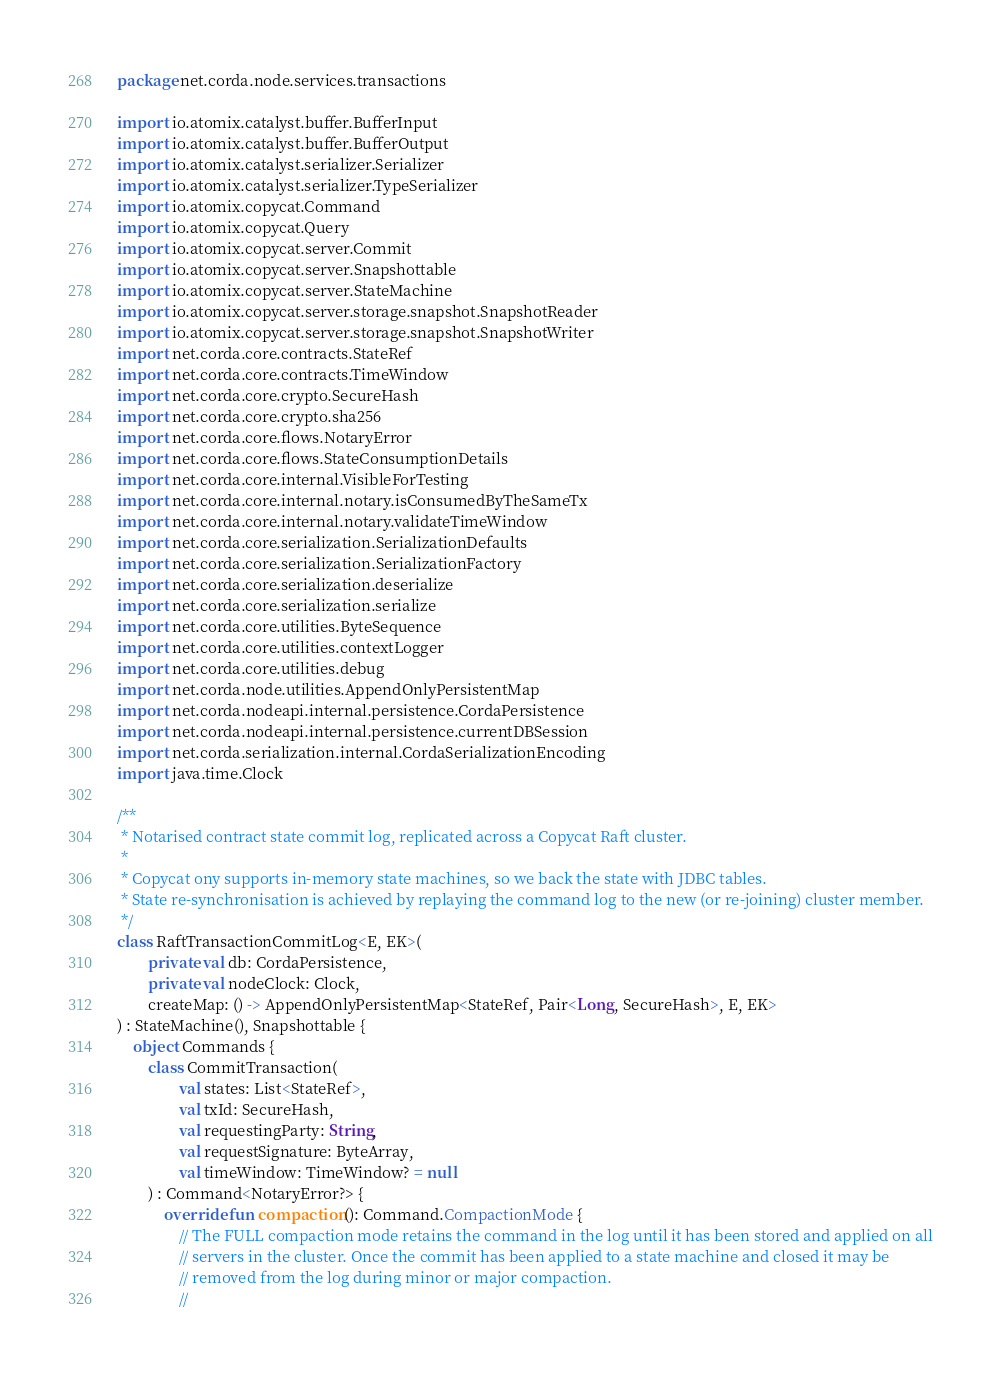Convert code to text. <code><loc_0><loc_0><loc_500><loc_500><_Kotlin_>package net.corda.node.services.transactions

import io.atomix.catalyst.buffer.BufferInput
import io.atomix.catalyst.buffer.BufferOutput
import io.atomix.catalyst.serializer.Serializer
import io.atomix.catalyst.serializer.TypeSerializer
import io.atomix.copycat.Command
import io.atomix.copycat.Query
import io.atomix.copycat.server.Commit
import io.atomix.copycat.server.Snapshottable
import io.atomix.copycat.server.StateMachine
import io.atomix.copycat.server.storage.snapshot.SnapshotReader
import io.atomix.copycat.server.storage.snapshot.SnapshotWriter
import net.corda.core.contracts.StateRef
import net.corda.core.contracts.TimeWindow
import net.corda.core.crypto.SecureHash
import net.corda.core.crypto.sha256
import net.corda.core.flows.NotaryError
import net.corda.core.flows.StateConsumptionDetails
import net.corda.core.internal.VisibleForTesting
import net.corda.core.internal.notary.isConsumedByTheSameTx
import net.corda.core.internal.notary.validateTimeWindow
import net.corda.core.serialization.SerializationDefaults
import net.corda.core.serialization.SerializationFactory
import net.corda.core.serialization.deserialize
import net.corda.core.serialization.serialize
import net.corda.core.utilities.ByteSequence
import net.corda.core.utilities.contextLogger
import net.corda.core.utilities.debug
import net.corda.node.utilities.AppendOnlyPersistentMap
import net.corda.nodeapi.internal.persistence.CordaPersistence
import net.corda.nodeapi.internal.persistence.currentDBSession
import net.corda.serialization.internal.CordaSerializationEncoding
import java.time.Clock

/**
 * Notarised contract state commit log, replicated across a Copycat Raft cluster.
 *
 * Copycat ony supports in-memory state machines, so we back the state with JDBC tables.
 * State re-synchronisation is achieved by replaying the command log to the new (or re-joining) cluster member.
 */
class RaftTransactionCommitLog<E, EK>(
        private val db: CordaPersistence,
        private val nodeClock: Clock,
        createMap: () -> AppendOnlyPersistentMap<StateRef, Pair<Long, SecureHash>, E, EK>
) : StateMachine(), Snapshottable {
    object Commands {
        class CommitTransaction(
                val states: List<StateRef>,
                val txId: SecureHash,
                val requestingParty: String,
                val requestSignature: ByteArray,
                val timeWindow: TimeWindow? = null
        ) : Command<NotaryError?> {
            override fun compaction(): Command.CompactionMode {
                // The FULL compaction mode retains the command in the log until it has been stored and applied on all
                // servers in the cluster. Once the commit has been applied to a state machine and closed it may be
                // removed from the log during minor or major compaction.
                //</code> 